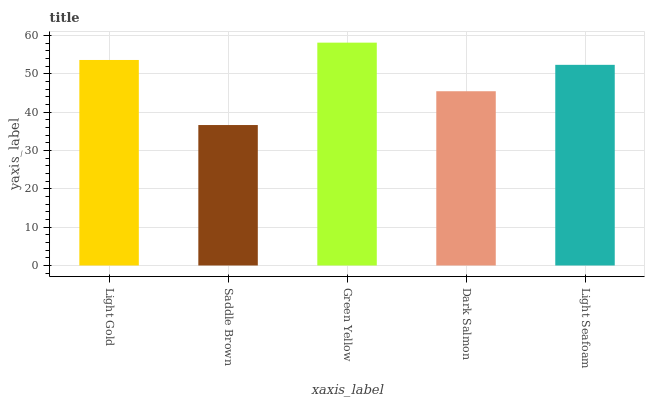Is Saddle Brown the minimum?
Answer yes or no. Yes. Is Green Yellow the maximum?
Answer yes or no. Yes. Is Green Yellow the minimum?
Answer yes or no. No. Is Saddle Brown the maximum?
Answer yes or no. No. Is Green Yellow greater than Saddle Brown?
Answer yes or no. Yes. Is Saddle Brown less than Green Yellow?
Answer yes or no. Yes. Is Saddle Brown greater than Green Yellow?
Answer yes or no. No. Is Green Yellow less than Saddle Brown?
Answer yes or no. No. Is Light Seafoam the high median?
Answer yes or no. Yes. Is Light Seafoam the low median?
Answer yes or no. Yes. Is Saddle Brown the high median?
Answer yes or no. No. Is Light Gold the low median?
Answer yes or no. No. 